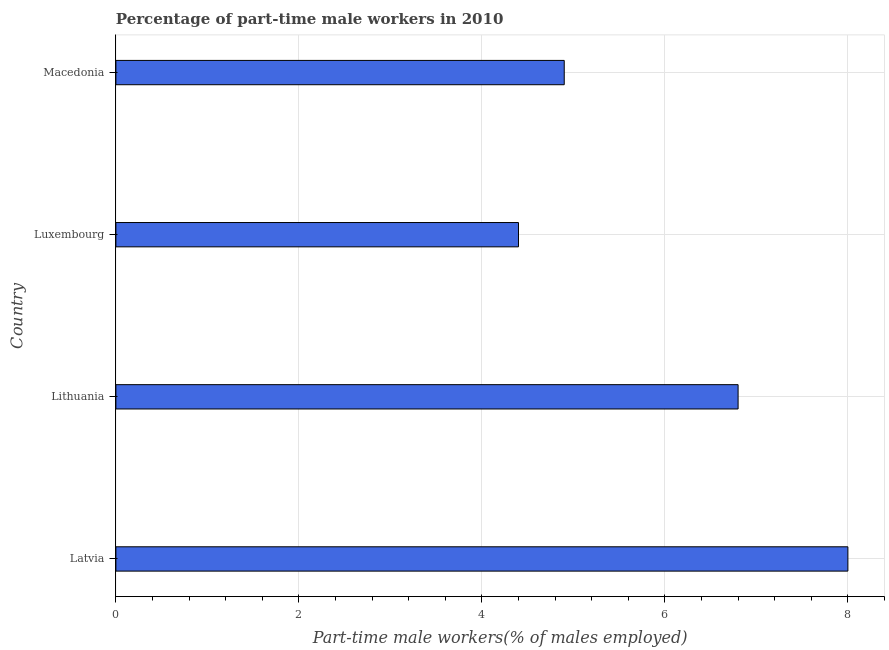Does the graph contain grids?
Your answer should be very brief. Yes. What is the title of the graph?
Provide a short and direct response. Percentage of part-time male workers in 2010. What is the label or title of the X-axis?
Provide a short and direct response. Part-time male workers(% of males employed). Across all countries, what is the minimum percentage of part-time male workers?
Give a very brief answer. 4.4. In which country was the percentage of part-time male workers maximum?
Your answer should be very brief. Latvia. In which country was the percentage of part-time male workers minimum?
Your answer should be compact. Luxembourg. What is the sum of the percentage of part-time male workers?
Provide a succinct answer. 24.1. What is the difference between the percentage of part-time male workers in Latvia and Luxembourg?
Provide a succinct answer. 3.6. What is the average percentage of part-time male workers per country?
Offer a very short reply. 6.03. What is the median percentage of part-time male workers?
Offer a terse response. 5.85. What is the ratio of the percentage of part-time male workers in Lithuania to that in Luxembourg?
Provide a succinct answer. 1.54. Is the difference between the percentage of part-time male workers in Latvia and Lithuania greater than the difference between any two countries?
Your response must be concise. No. Is the sum of the percentage of part-time male workers in Lithuania and Macedonia greater than the maximum percentage of part-time male workers across all countries?
Your answer should be compact. Yes. In how many countries, is the percentage of part-time male workers greater than the average percentage of part-time male workers taken over all countries?
Your response must be concise. 2. How many countries are there in the graph?
Ensure brevity in your answer.  4. Are the values on the major ticks of X-axis written in scientific E-notation?
Ensure brevity in your answer.  No. What is the Part-time male workers(% of males employed) in Latvia?
Offer a very short reply. 8. What is the Part-time male workers(% of males employed) in Lithuania?
Make the answer very short. 6.8. What is the Part-time male workers(% of males employed) in Luxembourg?
Offer a very short reply. 4.4. What is the Part-time male workers(% of males employed) in Macedonia?
Your response must be concise. 4.9. What is the difference between the Part-time male workers(% of males employed) in Latvia and Lithuania?
Keep it short and to the point. 1.2. What is the difference between the Part-time male workers(% of males employed) in Latvia and Luxembourg?
Offer a very short reply. 3.6. What is the difference between the Part-time male workers(% of males employed) in Latvia and Macedonia?
Your response must be concise. 3.1. What is the difference between the Part-time male workers(% of males employed) in Lithuania and Luxembourg?
Your answer should be compact. 2.4. What is the difference between the Part-time male workers(% of males employed) in Luxembourg and Macedonia?
Give a very brief answer. -0.5. What is the ratio of the Part-time male workers(% of males employed) in Latvia to that in Lithuania?
Make the answer very short. 1.18. What is the ratio of the Part-time male workers(% of males employed) in Latvia to that in Luxembourg?
Provide a short and direct response. 1.82. What is the ratio of the Part-time male workers(% of males employed) in Latvia to that in Macedonia?
Provide a short and direct response. 1.63. What is the ratio of the Part-time male workers(% of males employed) in Lithuania to that in Luxembourg?
Make the answer very short. 1.54. What is the ratio of the Part-time male workers(% of males employed) in Lithuania to that in Macedonia?
Your answer should be compact. 1.39. What is the ratio of the Part-time male workers(% of males employed) in Luxembourg to that in Macedonia?
Offer a terse response. 0.9. 